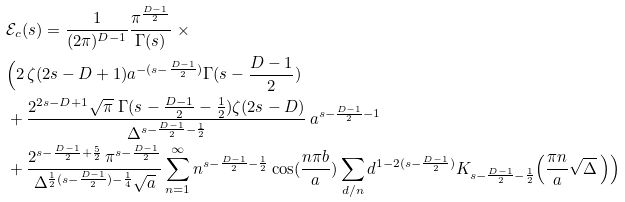Convert formula to latex. <formula><loc_0><loc_0><loc_500><loc_500>& \mathcal { E } _ { c } ( s ) = \frac { 1 } { ( 2 \pi ) ^ { D - 1 } } \frac { \pi ^ { \frac { D - 1 } { 2 } } } { \Gamma ( s ) } { \, } { \, } \times \\ & \Big { ( } 2 { \, } \zeta ( 2 s - D + 1 ) a ^ { - ( s - \frac { D - 1 } { 2 } ) } \Gamma ( s - \frac { D - 1 } { 2 } ) \\ & + \frac { 2 ^ { 2 s - D + 1 } \sqrt { \pi } { \, } { \, } \Gamma ( s - \frac { D - 1 } { 2 } - \frac { 1 } { 2 } ) \zeta ( 2 s - D ) } { \Delta ^ { s - \frac { D - 1 } { 2 } - \frac { 1 } { 2 } } } { \, } a ^ { s - \frac { D - 1 } { 2 } - 1 } \\ & + \frac { 2 ^ { s - \frac { D - 1 } { 2 } + \frac { 5 } { 2 } } { \, } \pi ^ { s - \frac { D - 1 } { 2 } } } { \Delta ^ { \frac { 1 } { 2 } ( s - \frac { D - 1 } { 2 } ) - \frac { 1 } { 4 } } \sqrt { a } } \sum _ { n = 1 } ^ { \infty } n ^ { s - \frac { D - 1 } { 2 } - \frac { 1 } { 2 } } \cos ( \frac { n \pi b } { a } ) \sum _ { d / n } d ^ { 1 - 2 ( s - \frac { D - 1 } { 2 } ) } K _ { s - \frac { D - 1 } { 2 } - \frac { 1 } { 2 } } \Big { ( } \frac { \pi n } { a } \sqrt { \Delta } { \, } \Big { ) } \Big { ) }</formula> 